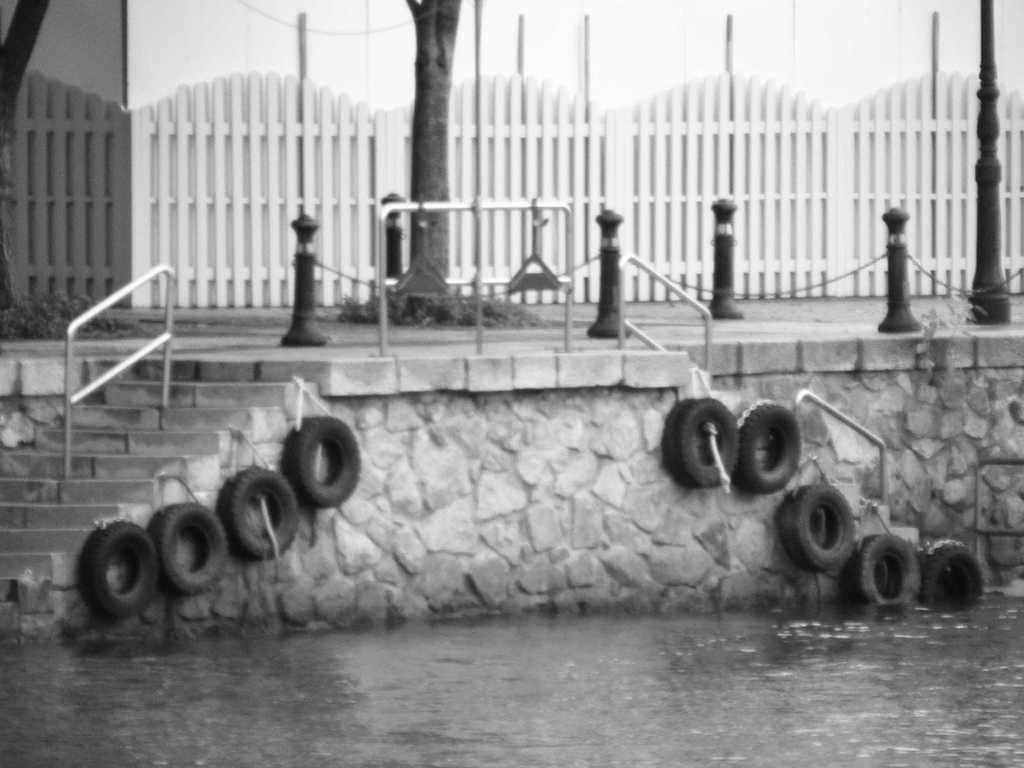What is the main feature of the image? The main feature of the image is a water surface. What structures are located behind the water surface? There are steps with railings behind the water surface. What other objects can be seen in the image? There is a pole visible in the image. What is the background of the pole? There is a building wall behind the pole. How many snails can be seen crawling on the water surface in the image? There are no snails visible on the water surface in the image. What type of scissors are being used to cut the river in the image? There is no river or scissors present in the image. 